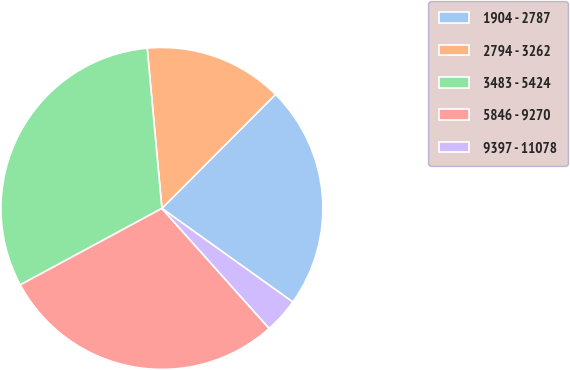Convert chart. <chart><loc_0><loc_0><loc_500><loc_500><pie_chart><fcel>1904 - 2787<fcel>2794 - 3262<fcel>3483 - 5424<fcel>5846 - 9270<fcel>9397 - 11078<nl><fcel>22.41%<fcel>13.93%<fcel>31.42%<fcel>28.73%<fcel>3.51%<nl></chart> 